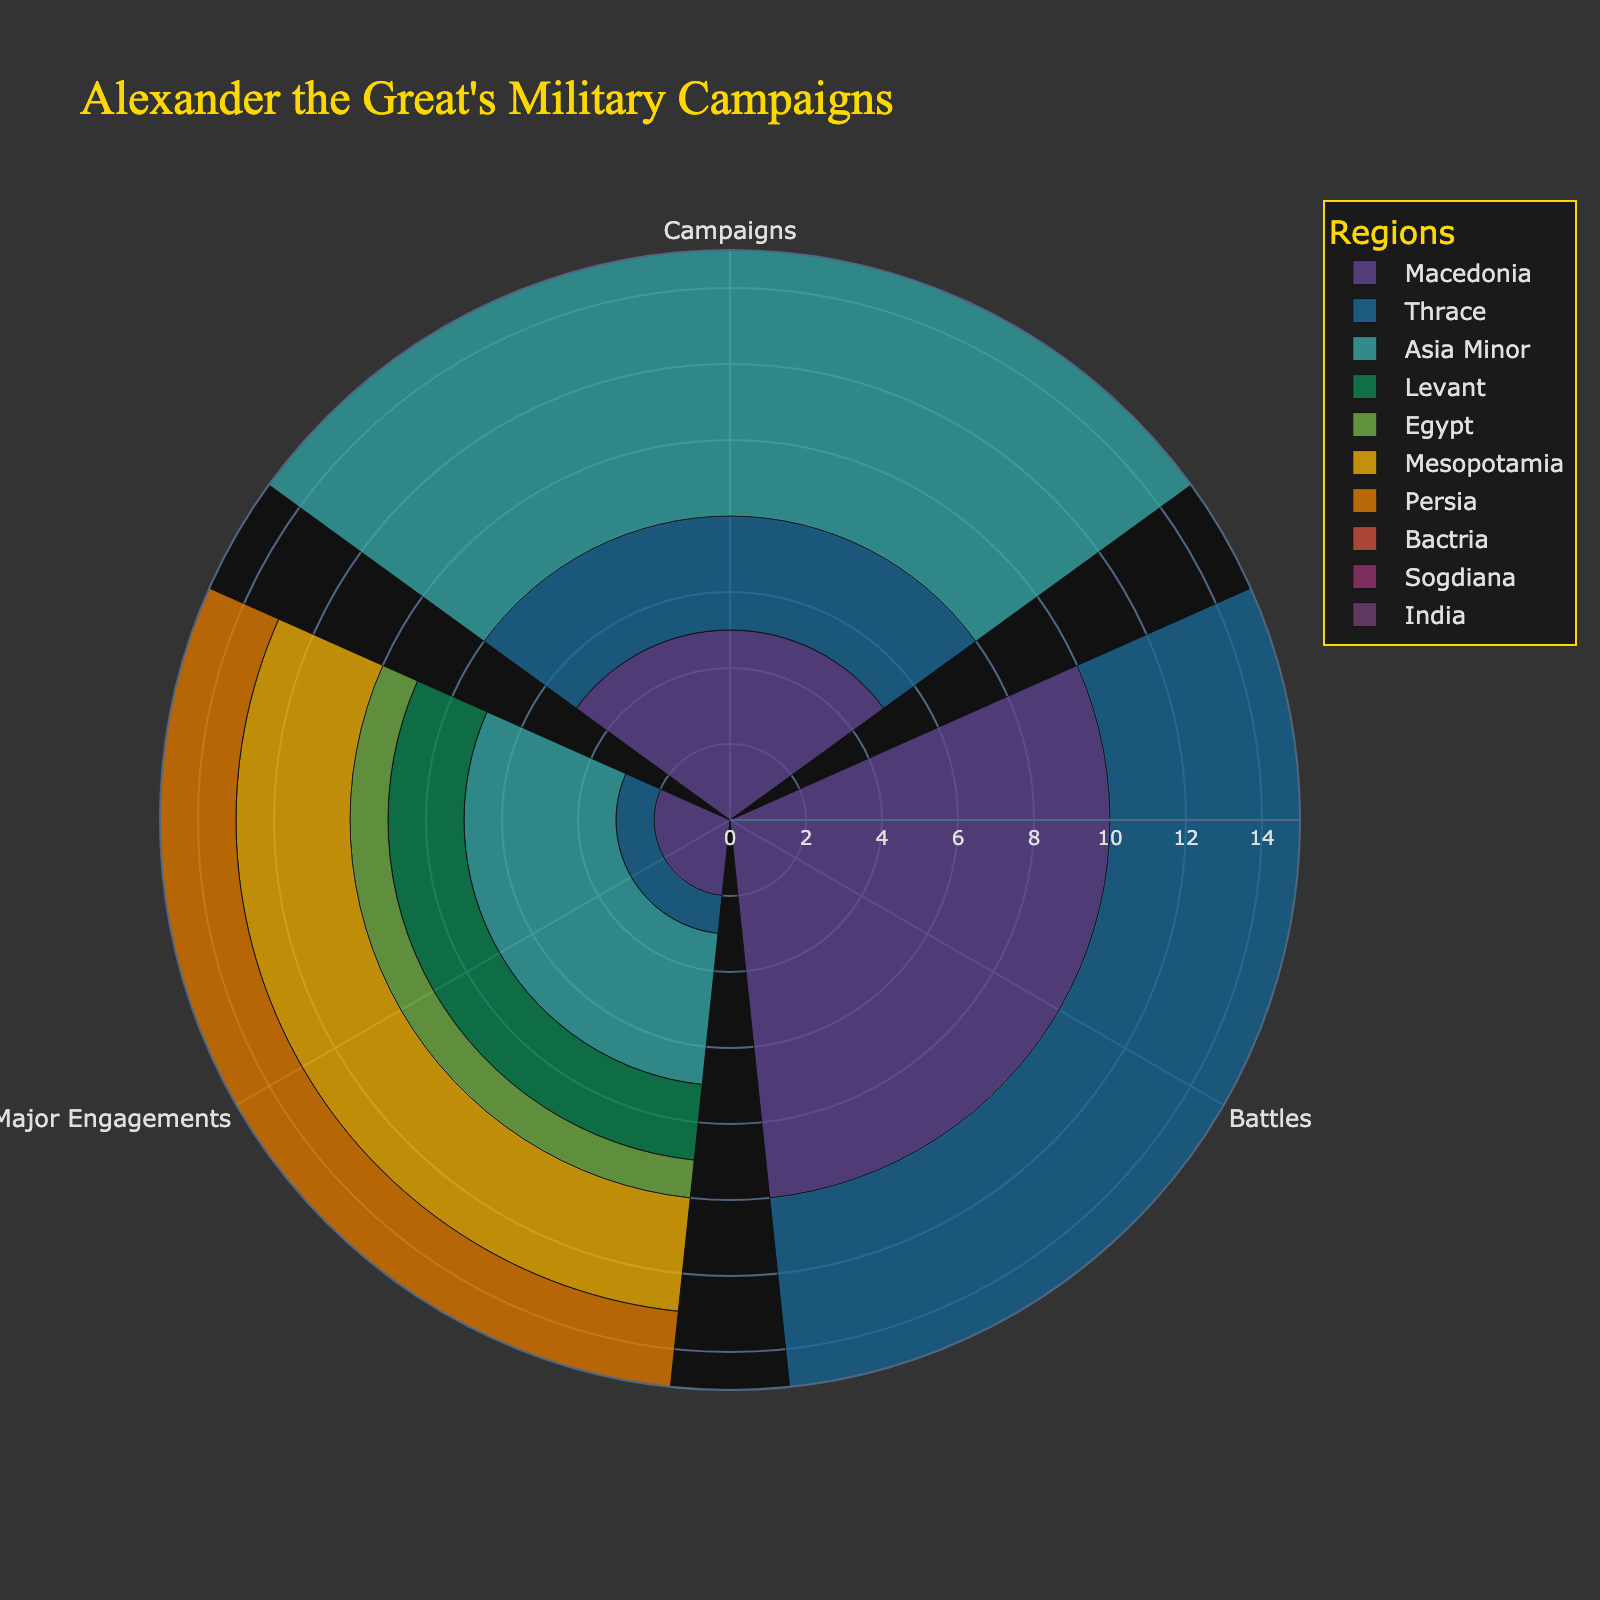what is the title of the figure? The title is usually placed at the top, often in a larger or bolder font which can be immediately seen upon looking at the chart. In this figure, the title is "Alexander the Great's Military Campaigns"
Answer: "Alexander the Great's Military Campaigns" What regions have more than 10 battles? To determine this, look at the bar length for the 'Total Battles' section of each region. If the length surpasses the 10 mark on the radial axis, that region qualifies. Persia, Mesopotamia, Asia Minor, and India all have between 10 and 15 battles shown.
Answer: Persia, Mesopotamia, Asia Minor, and India Which region had the most Major Engagements? To identify which region had the most major engagements, observe the bar lengths for the "Major Engagements" section. The longest bar in this section corresponds to Persia, which has the highest count.
Answer: Persia What is the total number of campaigns in Macedonia and Bactria combined? List the number of campaigns for each region: Macedonia has 5 and Bactria has 5. Adding 5 + 5 gives 10.
Answer: 10 How does the number of battles in Egypt compare to those in Levant? Egypt has 4 battles while the Levant has 7. To compare, note that 4 is less than 7. Therefore, Egypt has fewer battles than Levant.
Answer: Egypt has fewer battles What was the region with the highest combined number of campaigns and battles? Summarize the campaigns and battles for each region then find the highest total. Combining Macedonia (5+10=15), Thrace (3+5=8), Asia Minor (8+15=23), Levant (4+7=11), Egypt (2+4=6), Mesopotamia (6+11=17), Persia (7+14=21), Bactria (5+9=14), Sogdiana (4+6=10), and India (3+8=11). The highest combined total is Asia Minor with 23.
Answer: Asia Minor Which regions had exactly 2 major engagements? Check the bar lengths specific to "Major Engagements". Macedonia, Levant, Bactria, and Sogdiana each have bars indicating exactly 2 major engagements.
Answer: Macedonia, Levant, Bactria, and Sogdiana How many regions participated in more than 7 campaigns? Review the 'Number of Campaigns' bars for each region and count how many exceed the 7 mark. These regions would be Asia Minor (8) and Persia (7). However, since 7 is not greater than 7, the number is only Asia Minor.
Answer: 1 region (Asia Minor) Which region had the least number of major engagements and how many were there? The region with the smallest bar length in the "Major Engagements" category will have the least major engagements. Egypt had the shortest bar with 1 major engagement.
Answer: Egypt, 1 